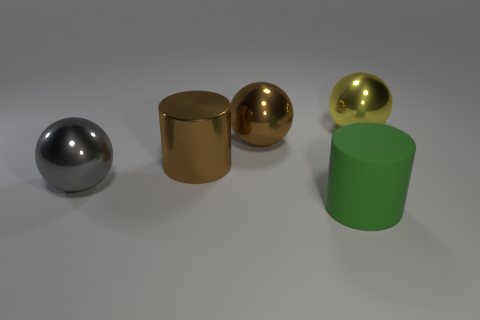How many objects are either gray metallic things or large metallic objects?
Provide a succinct answer. 4. Is there another cylinder that has the same color as the matte cylinder?
Provide a short and direct response. No. There is a big brown object that is on the right side of the brown metal cylinder; how many large metal objects are on the left side of it?
Ensure brevity in your answer.  2. Is the number of big brown metal balls greater than the number of shiny objects?
Offer a very short reply. No. Is the big yellow ball made of the same material as the large green cylinder?
Keep it short and to the point. No. Is the number of green rubber things that are right of the yellow object the same as the number of rubber cubes?
Ensure brevity in your answer.  Yes. What number of gray spheres have the same material as the brown sphere?
Your answer should be compact. 1. Are there fewer large matte things than cylinders?
Offer a very short reply. Yes. There is a brown metallic object that is on the right side of the cylinder that is behind the gray thing; what number of big objects are on the right side of it?
Make the answer very short. 2. What number of metal objects are right of the large green thing?
Provide a succinct answer. 1. 